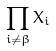Convert formula to latex. <formula><loc_0><loc_0><loc_500><loc_500>\prod _ { i \ne \beta } X _ { i }</formula> 